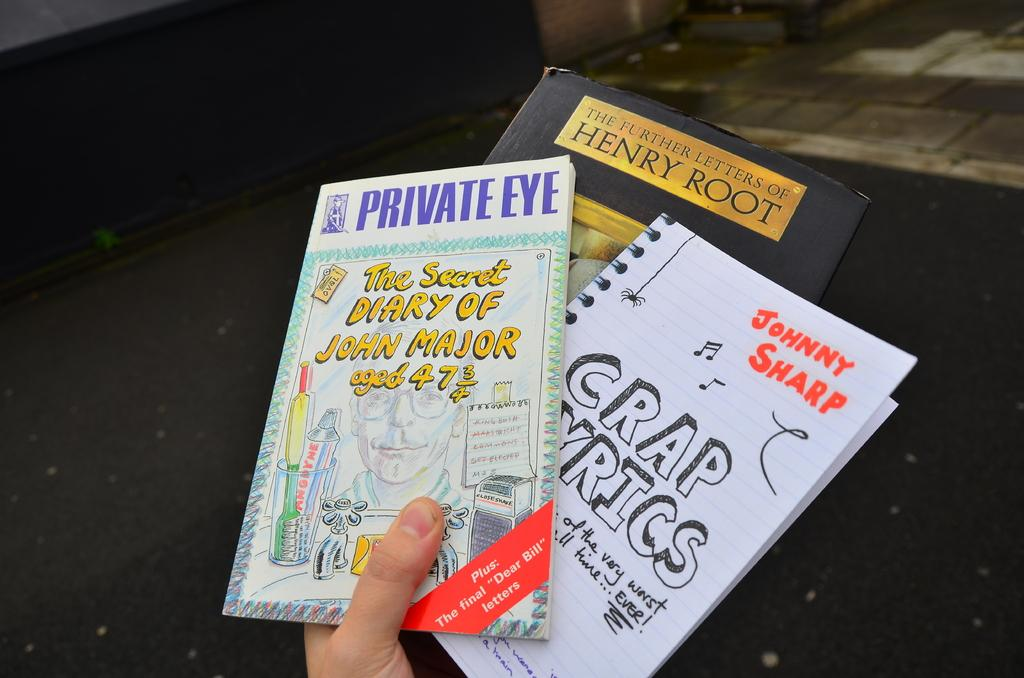Provide a one-sentence caption for the provided image. Three books including crap lyrics, private eye the secret diary of John Major aged 47 3/4, and the Further Letters of Henry Root. 